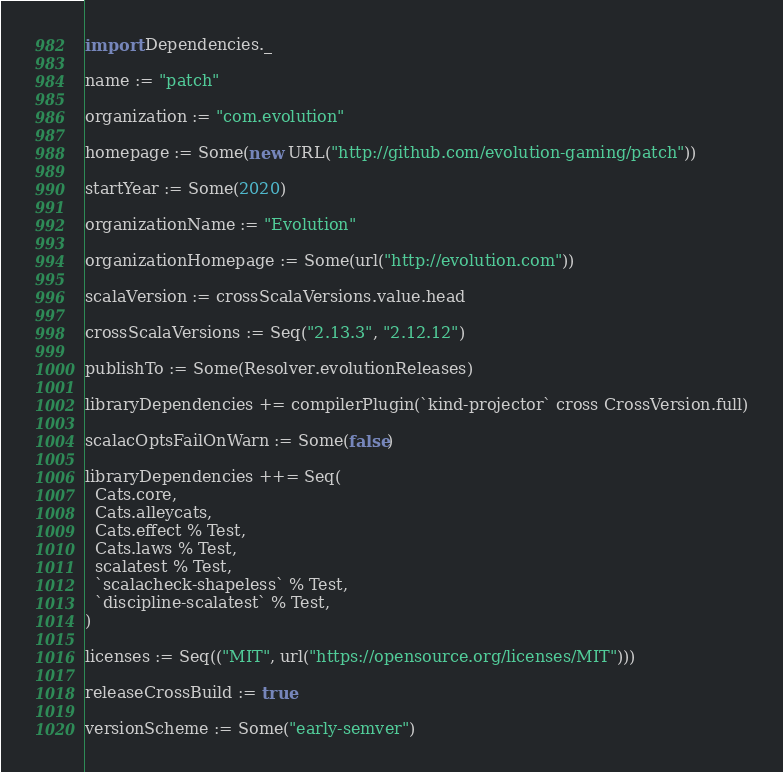<code> <loc_0><loc_0><loc_500><loc_500><_Scala_>import Dependencies._

name := "patch"

organization := "com.evolution"

homepage := Some(new URL("http://github.com/evolution-gaming/patch"))

startYear := Some(2020)

organizationName := "Evolution"

organizationHomepage := Some(url("http://evolution.com"))

scalaVersion := crossScalaVersions.value.head

crossScalaVersions := Seq("2.13.3", "2.12.12")

publishTo := Some(Resolver.evolutionReleases)

libraryDependencies += compilerPlugin(`kind-projector` cross CrossVersion.full)

scalacOptsFailOnWarn := Some(false)

libraryDependencies ++= Seq(
  Cats.core,
  Cats.alleycats,
  Cats.effect % Test,
  Cats.laws % Test,
  scalatest % Test,
  `scalacheck-shapeless` % Test,
  `discipline-scalatest` % Test,
)

licenses := Seq(("MIT", url("https://opensource.org/licenses/MIT")))

releaseCrossBuild := true

versionScheme := Some("early-semver")
</code> 